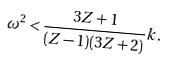<formula> <loc_0><loc_0><loc_500><loc_500>\omega ^ { 2 } < \frac { 3 Z + 1 } { ( Z - 1 ) ( 3 Z + 2 ) } k .</formula> 